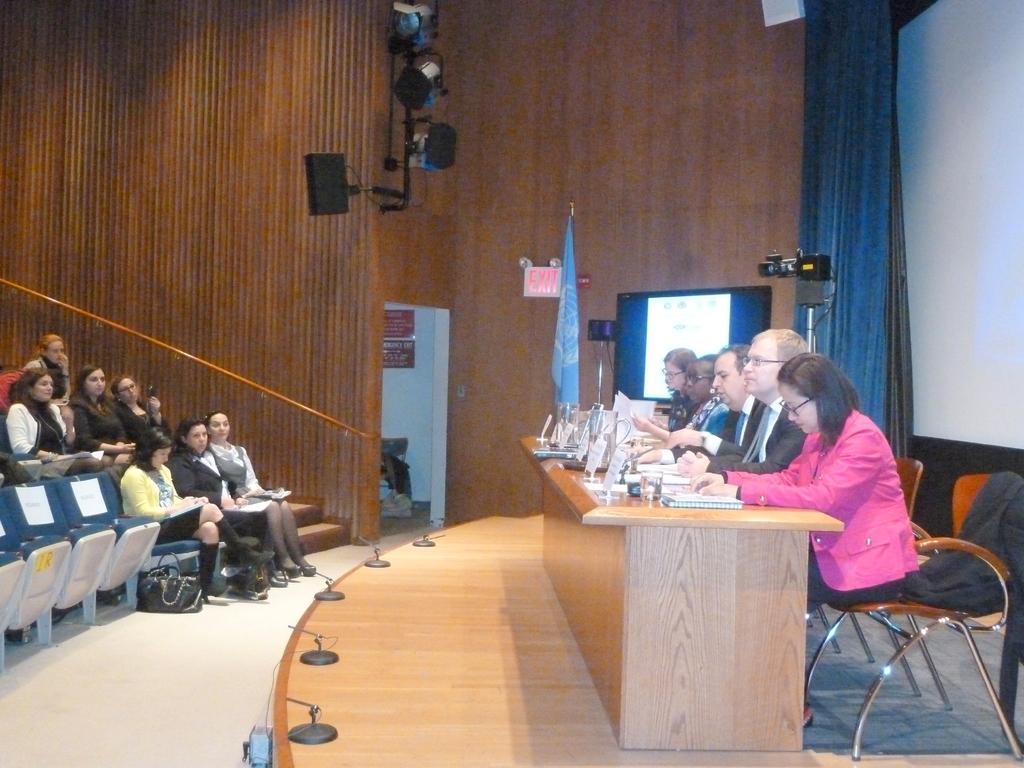Can you describe this image briefly? On the right side of the image we can see a screen, lights, flag, camera with stand and some people are sitting on the chairs. In-front of them, we can see a table. On the table we can see the boards, books, papers and some other objects. On the left side of the image we can see some people are sitting on the chairs and some of them are holding papers. In the background of the image we can see the wall, bag, boards on the wall, speaker, lights, curtain. At the bottom of the image we can see the floor. 